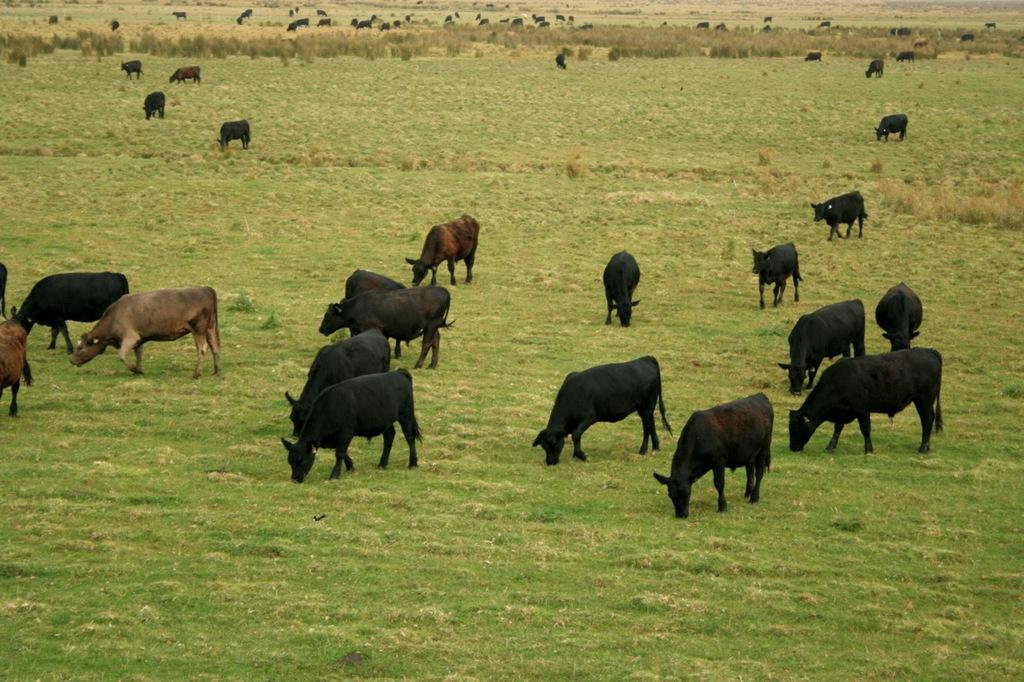What animals can be seen in the image? There are cows in the image. What are the cows doing in the image? Some of the cows are eating grass. What type of vegetation is present at the bottom of the image? Grass is present at the bottom of the image. What type of blade is being used by the team in the image? There is no team or blade present in the image; it features cows eating grass. 